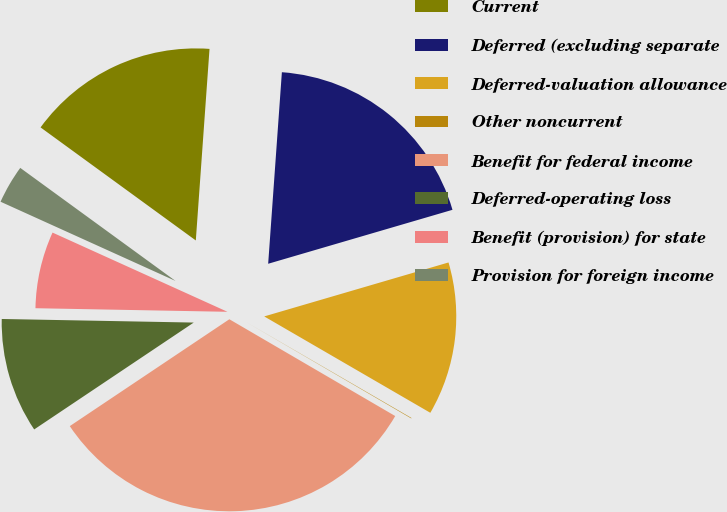Convert chart. <chart><loc_0><loc_0><loc_500><loc_500><pie_chart><fcel>Current<fcel>Deferred (excluding separate<fcel>Deferred-valuation allowance<fcel>Other noncurrent<fcel>Benefit for federal income<fcel>Deferred-operating loss<fcel>Benefit (provision) for state<fcel>Provision for foreign income<nl><fcel>16.12%<fcel>19.33%<fcel>12.9%<fcel>0.04%<fcel>32.2%<fcel>9.69%<fcel>6.47%<fcel>3.25%<nl></chart> 